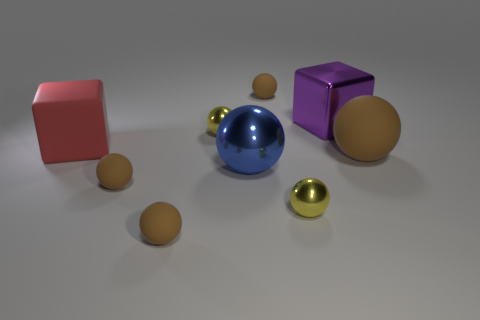What is the color of the big metallic cube?
Ensure brevity in your answer.  Purple. How many large objects are red objects or balls?
Give a very brief answer. 3. Is the block that is in front of the big purple block made of the same material as the yellow object that is in front of the large brown matte object?
Give a very brief answer. No. Are there any big gray metallic objects?
Offer a terse response. No. Is the number of matte cubes to the right of the metallic cube greater than the number of large brown matte things that are in front of the red matte cube?
Your answer should be compact. No. There is a purple object that is the same shape as the red thing; what is its material?
Give a very brief answer. Metal. Is there any other thing that is the same size as the metal block?
Ensure brevity in your answer.  Yes. Do the rubber sphere to the right of the purple object and the big metallic block that is to the right of the blue metal thing have the same color?
Provide a short and direct response. No. There is a purple metallic object; what shape is it?
Your answer should be very brief. Cube. Is the number of cubes that are to the right of the large purple thing greater than the number of matte balls?
Make the answer very short. No. 